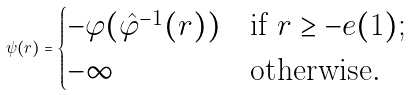<formula> <loc_0><loc_0><loc_500><loc_500>\psi ( r ) = \begin{cases} - \varphi ( \hat { \varphi } ^ { - 1 } ( r ) ) & \text {if } r \geq - e ( 1 ) ; \\ - \infty & \text {otherwise} . \end{cases}</formula> 